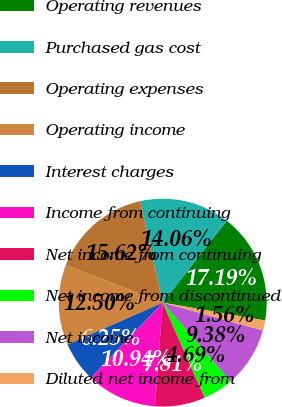Convert chart. <chart><loc_0><loc_0><loc_500><loc_500><pie_chart><fcel>Operating revenues<fcel>Purchased gas cost<fcel>Operating expenses<fcel>Operating income<fcel>Interest charges<fcel>Income from continuing<fcel>Net income from continuing<fcel>Net income from discontinued<fcel>Net income<fcel>Diluted net income from<nl><fcel>17.19%<fcel>14.06%<fcel>15.62%<fcel>12.5%<fcel>6.25%<fcel>10.94%<fcel>7.81%<fcel>4.69%<fcel>9.38%<fcel>1.56%<nl></chart> 